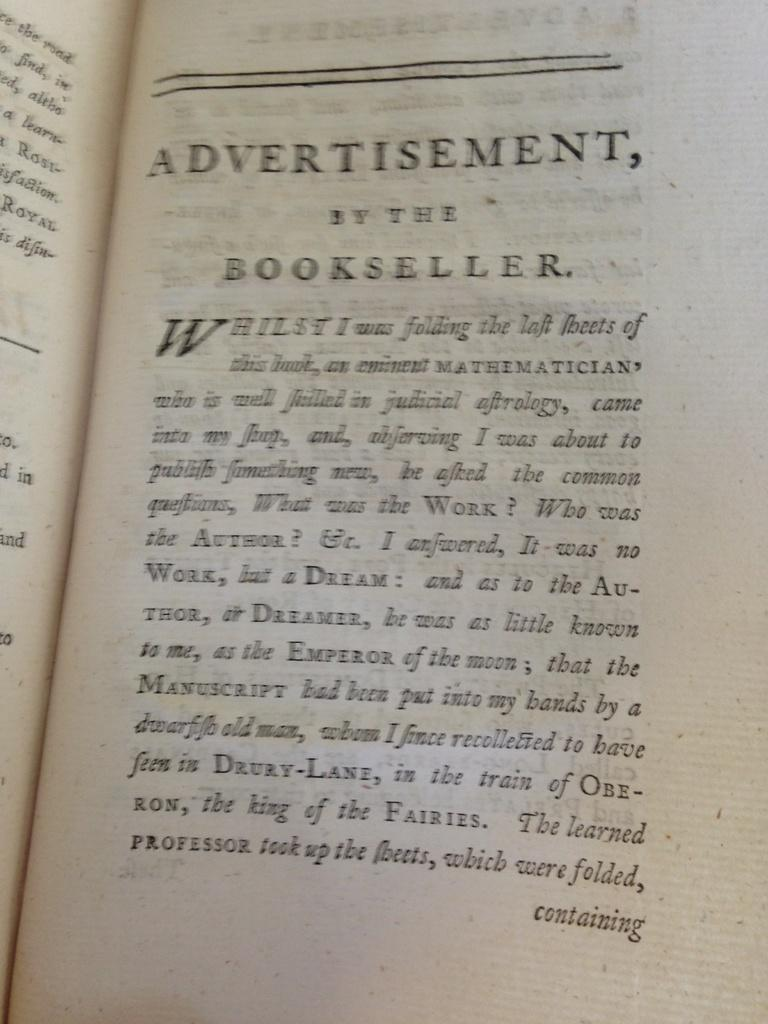<image>
Share a concise interpretation of the image provided. A book from the past is opened to a page titled Advertisement by the Bookseller. 